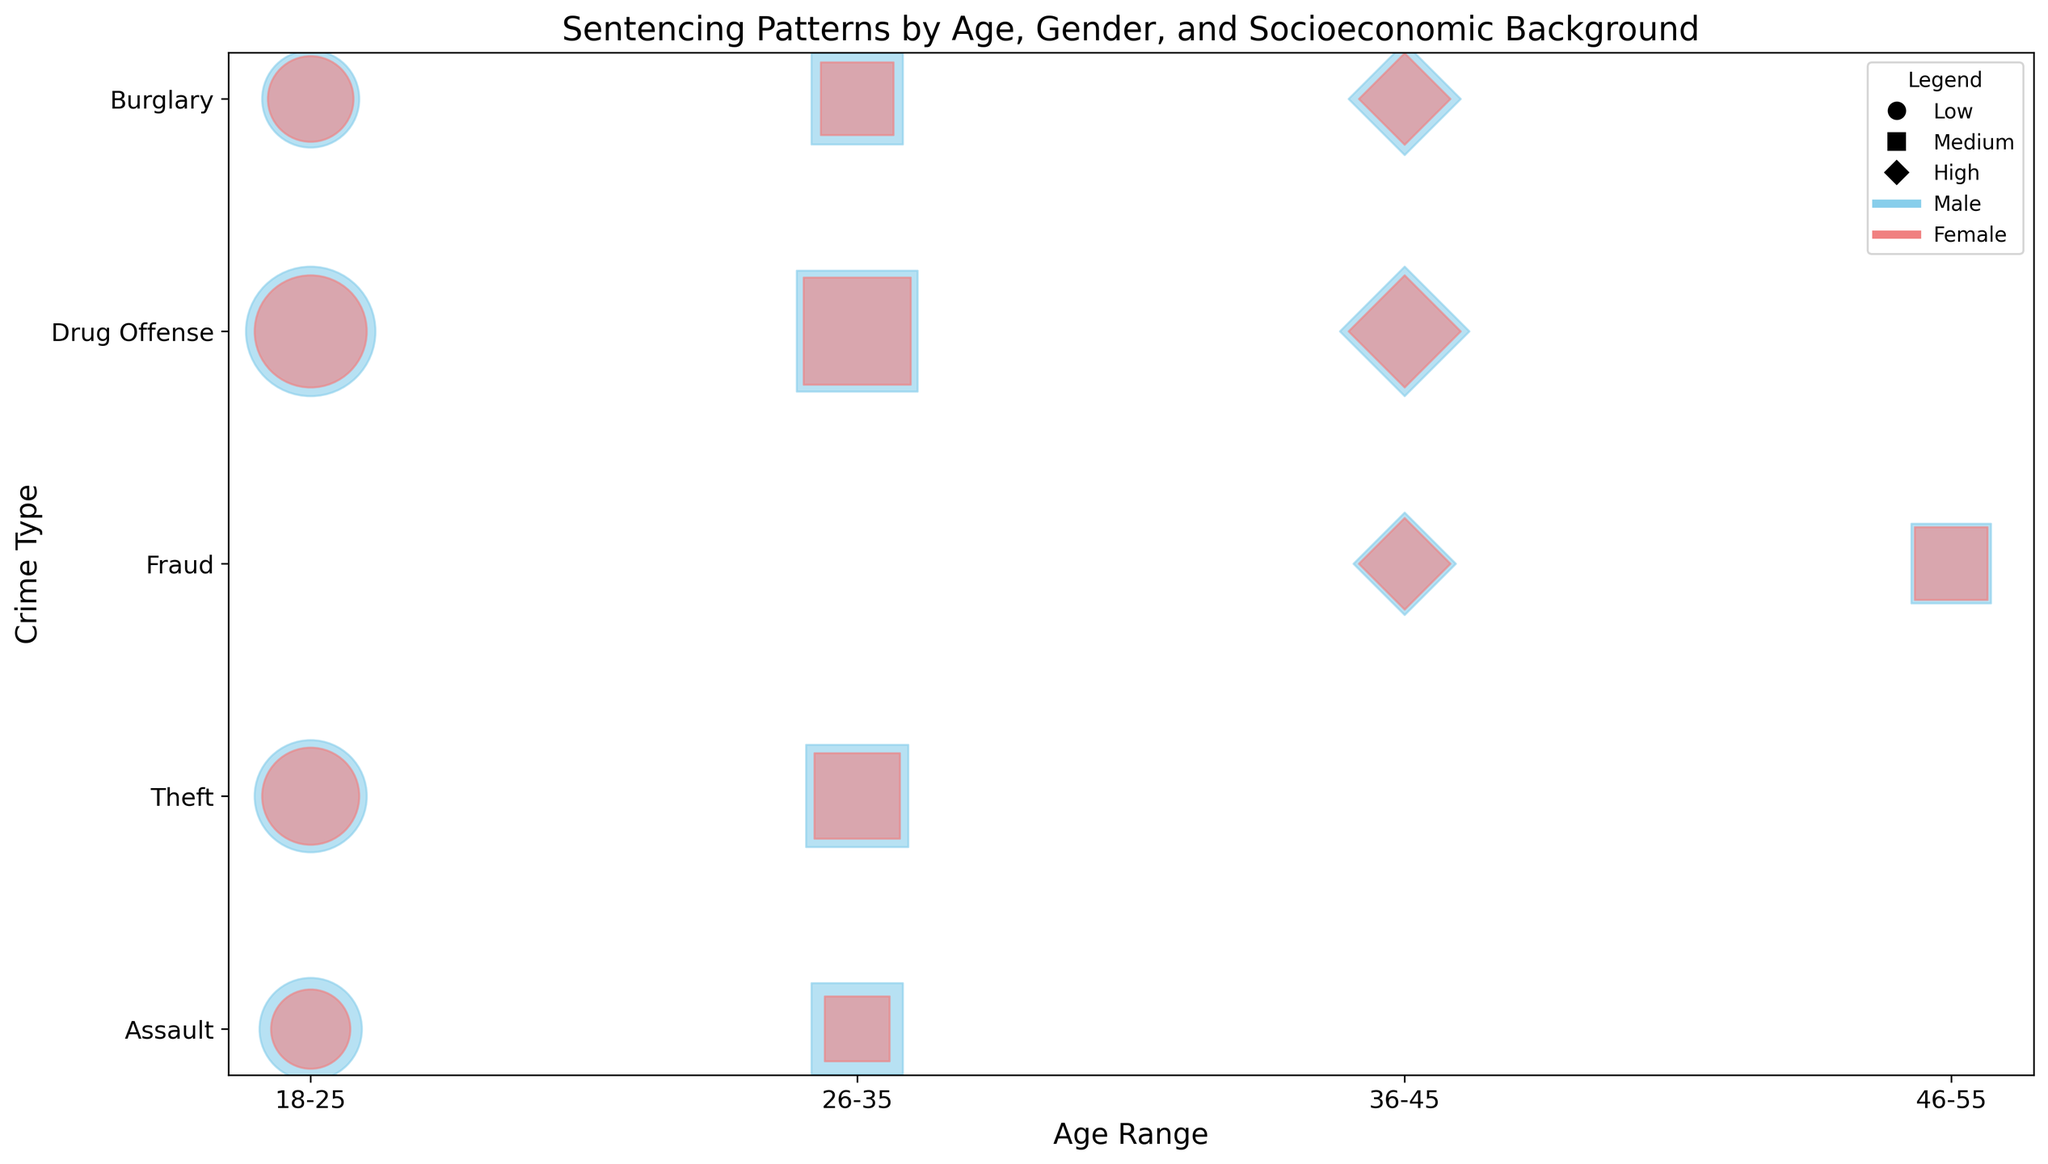Which socioeconomic background has the most cases for fraud? Look at the bubble size for "Fraud" and compare the markers representing different socioeconomic backgrounds. The largest bubbles represent the most cases.
Answer: Medium Who has longer sentencing lengths for drug offenses, males or females aged 18-25? Examine the bubble positions along the y-axis for "Drug Offense" and find the ones for males and females in the 18-25 age range. Compare the relative sizes and positions of the bubbles.
Answer: Males Are there more cases of theft or fraud in the high socioeconomic background category? Compare the bubble sizes for "Theft" and "Fraud" where the marker shape represents the high socioeconomic background.
Answer: Fraud Which crime type has the highest sentencing length for any gender and socioeconomic background within the 26-35 age range? Look at the bubbles within the 26-35 age range and compare the positions along the y-axis. Identify the highest position.
Answer: Burglary How do sentencing lengths for males and females compare for assault in the 18-25 age range? Look at the bubbles for "Assault" in the 18-25 age range and compare the vertical positions (sentencing lengths) of the bubbles for males and females.
Answer: Males have longer sentences Which gender has more cases of burglary in the high socioeconomic background for ages 36-45? Compare the bubble sizes for "Burglary" within the 36-45 age range and high socioeconomic background, distinguished by the color representing gender.
Answer: Males What is the visual pattern seen for theft cases in the low socioeconomic background for the 18-25 age range based on gender? Observe the bubble sizes and colors for "Theft" in the 18-25 age range and low socioeconomic background to see any noticeable trends.
Answer: More cases for males Which crime type shows the most significant difference in sentencing length between medium and high socioeconomic backgrounds for males aged 36-45? Compare the positions of bubbles for males aged 36-45 across different crime types, focusing on the difference between medium and high socioeconomic backgrounds.
Answer: Burglary What is the general trend in sentencing length for males with increasing socioeconomic background across all crime types? Look at the bubble positions for males across low, medium, and high socioeconomic backgrounds and observe the changes in sentencing lengths.
Answer: Sentencing length generally increases How do the number of cases for females involved in drug offenses in the medium socioeconomic background compare to those involved in theft in the same category? Compare the bubble sizes for females in the medium socioeconomic background for "Drug Offense" and "Theft".
Answer: More cases in drug offenses 